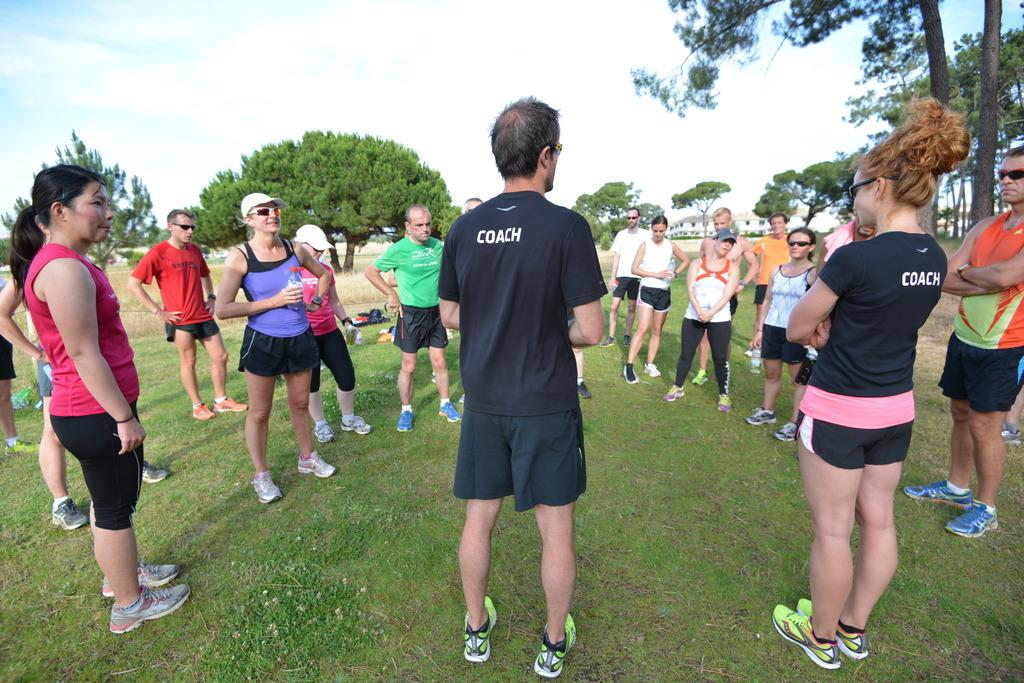How many people are in the image? There is a group of people in the image. Where are the people standing in the image? The people are standing on a grass path. What can be seen in the background of the image? There are trees and a building in the background of the image. What is the condition of the sky in the image? The sky is cloudy in the background of the image. What type of juice is being served to the people in the image? There is no juice present in the image; it features a group of people standing on a grass path with trees and a building in the background. 